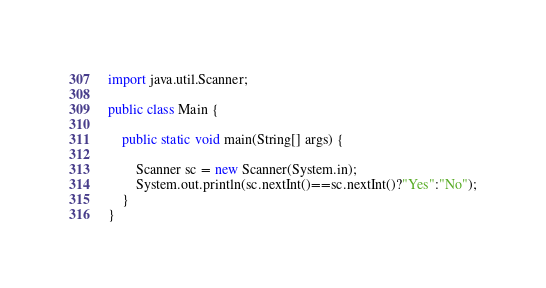<code> <loc_0><loc_0><loc_500><loc_500><_Java_>import java.util.Scanner;

public class Main {

	public static void main(String[] args) {

		Scanner sc = new Scanner(System.in);
		System.out.println(sc.nextInt()==sc.nextInt()?"Yes":"No");
	}
}
</code> 